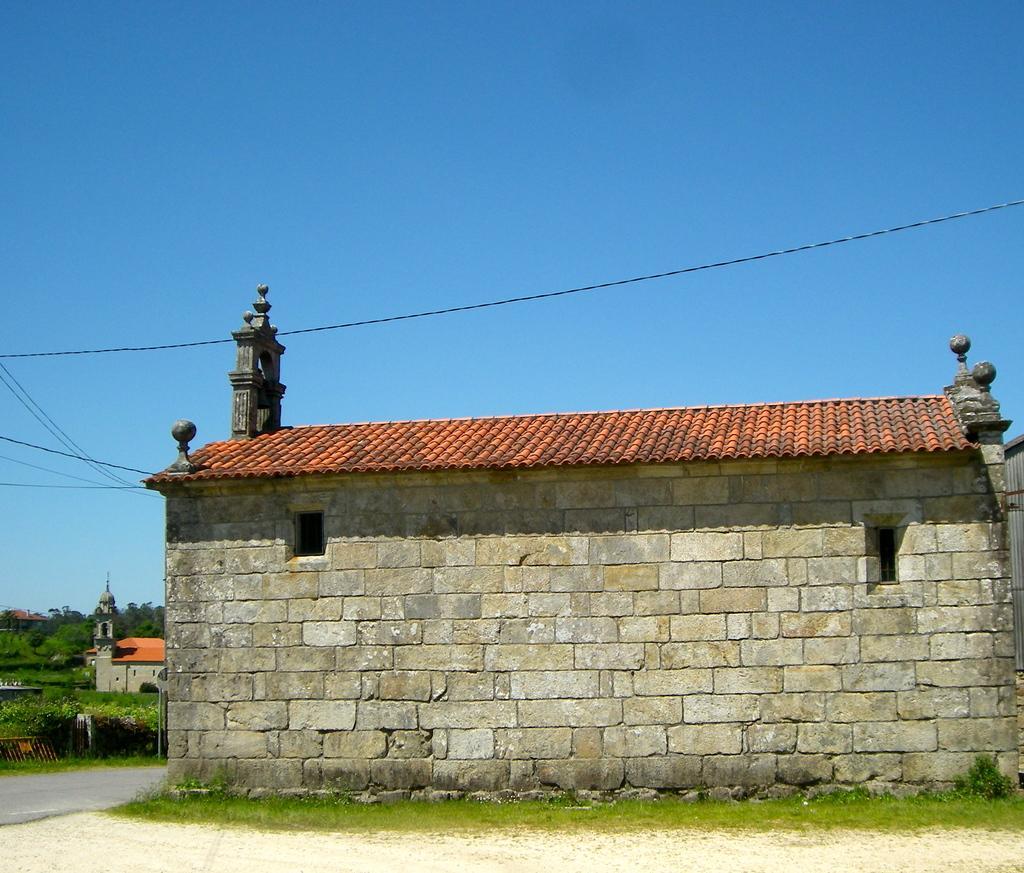How would you summarize this image in a sentence or two? In this image I can see few houses, trees, wires and small plants. The sky is in blue color. 